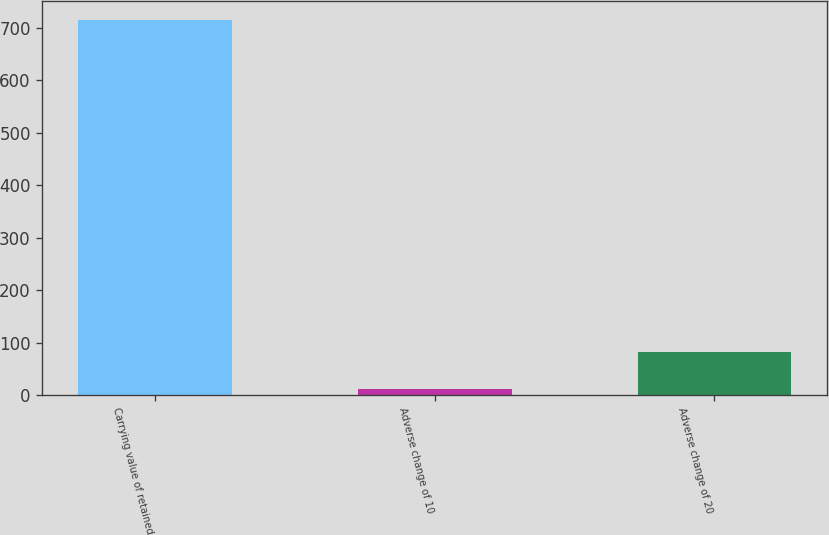<chart> <loc_0><loc_0><loc_500><loc_500><bar_chart><fcel>Carrying value of retained<fcel>Adverse change of 10<fcel>Adverse change of 20<nl><fcel>714<fcel>11<fcel>81.3<nl></chart> 